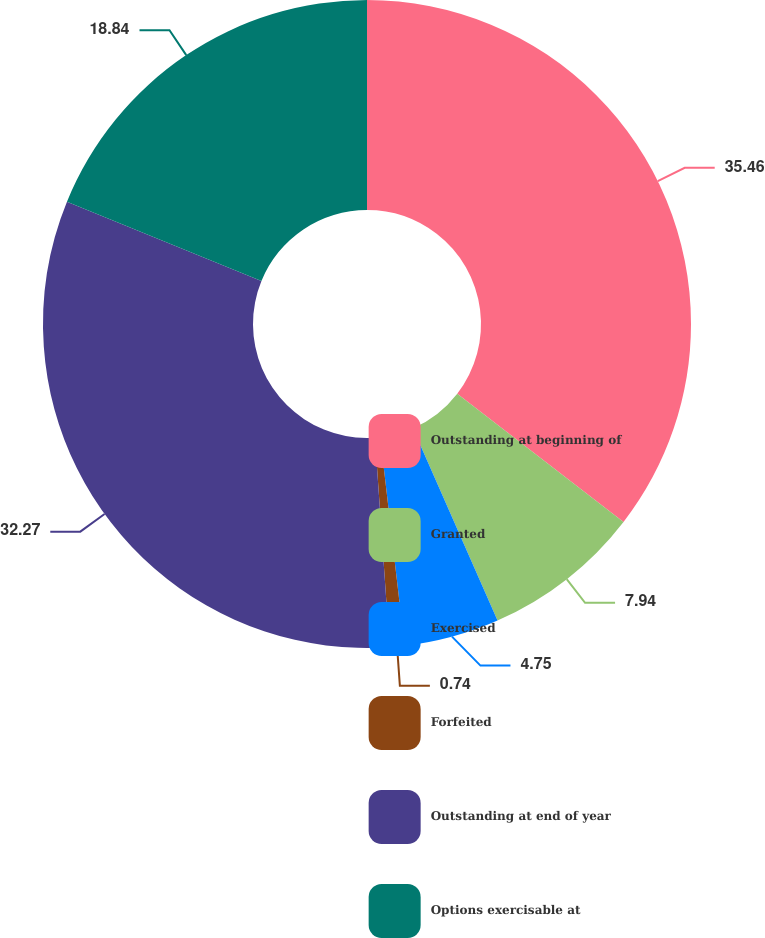Convert chart to OTSL. <chart><loc_0><loc_0><loc_500><loc_500><pie_chart><fcel>Outstanding at beginning of<fcel>Granted<fcel>Exercised<fcel>Forfeited<fcel>Outstanding at end of year<fcel>Options exercisable at<nl><fcel>35.46%<fcel>7.94%<fcel>4.75%<fcel>0.74%<fcel>32.27%<fcel>18.84%<nl></chart> 